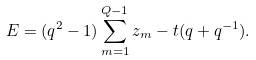Convert formula to latex. <formula><loc_0><loc_0><loc_500><loc_500>E = ( q ^ { 2 } - 1 ) \sum _ { m = 1 } ^ { Q - 1 } z _ { m } - t ( q + q ^ { - 1 } ) .</formula> 